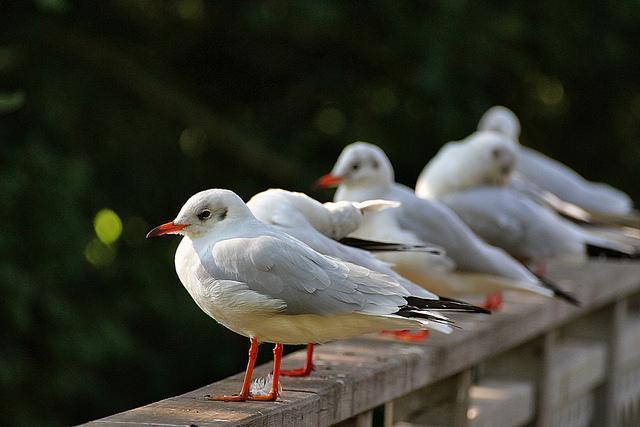How many birds are there?
Give a very brief answer. 5. How many breaks are there?
Give a very brief answer. 2. How many rings is the woman wearing?
Give a very brief answer. 0. 